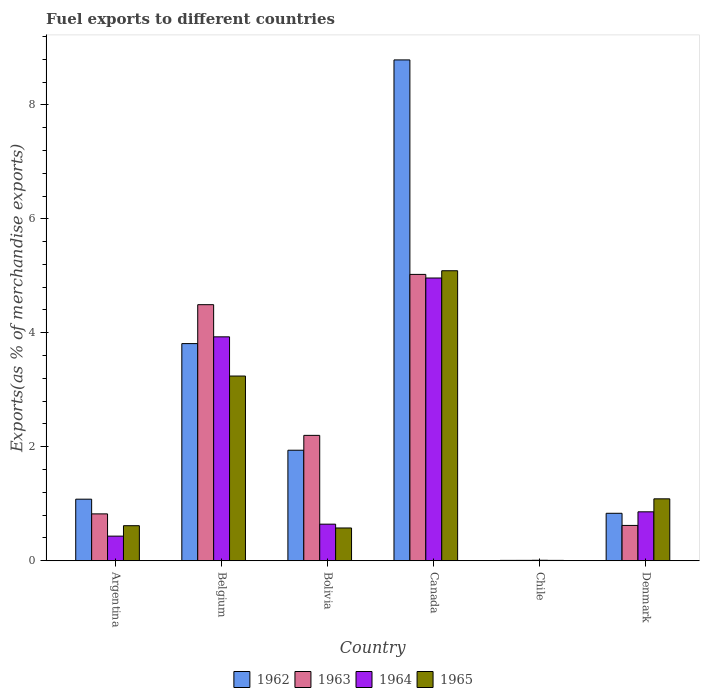Are the number of bars on each tick of the X-axis equal?
Provide a short and direct response. Yes. How many bars are there on the 2nd tick from the left?
Ensure brevity in your answer.  4. What is the percentage of exports to different countries in 1962 in Denmark?
Offer a very short reply. 0.83. Across all countries, what is the maximum percentage of exports to different countries in 1965?
Make the answer very short. 5.09. Across all countries, what is the minimum percentage of exports to different countries in 1963?
Ensure brevity in your answer.  0.01. What is the total percentage of exports to different countries in 1963 in the graph?
Provide a succinct answer. 13.17. What is the difference between the percentage of exports to different countries in 1964 in Bolivia and that in Denmark?
Your answer should be very brief. -0.22. What is the difference between the percentage of exports to different countries in 1964 in Denmark and the percentage of exports to different countries in 1962 in Belgium?
Provide a short and direct response. -2.95. What is the average percentage of exports to different countries in 1962 per country?
Provide a short and direct response. 2.74. What is the difference between the percentage of exports to different countries of/in 1964 and percentage of exports to different countries of/in 1963 in Belgium?
Offer a terse response. -0.56. In how many countries, is the percentage of exports to different countries in 1962 greater than 6 %?
Make the answer very short. 1. What is the ratio of the percentage of exports to different countries in 1963 in Belgium to that in Chile?
Offer a terse response. 634.23. Is the difference between the percentage of exports to different countries in 1964 in Argentina and Chile greater than the difference between the percentage of exports to different countries in 1963 in Argentina and Chile?
Offer a terse response. No. What is the difference between the highest and the second highest percentage of exports to different countries in 1964?
Keep it short and to the point. -3.07. What is the difference between the highest and the lowest percentage of exports to different countries in 1963?
Offer a very short reply. 5.02. Is it the case that in every country, the sum of the percentage of exports to different countries in 1964 and percentage of exports to different countries in 1963 is greater than the sum of percentage of exports to different countries in 1965 and percentage of exports to different countries in 1962?
Your response must be concise. No. What does the 1st bar from the left in Canada represents?
Offer a very short reply. 1962. What does the 1st bar from the right in Argentina represents?
Make the answer very short. 1965. Are all the bars in the graph horizontal?
Provide a short and direct response. No. How many countries are there in the graph?
Your answer should be very brief. 6. What is the difference between two consecutive major ticks on the Y-axis?
Your response must be concise. 2. Does the graph contain grids?
Offer a very short reply. No. How are the legend labels stacked?
Your answer should be very brief. Horizontal. What is the title of the graph?
Keep it short and to the point. Fuel exports to different countries. Does "1990" appear as one of the legend labels in the graph?
Offer a very short reply. No. What is the label or title of the Y-axis?
Provide a succinct answer. Exports(as % of merchandise exports). What is the Exports(as % of merchandise exports) of 1962 in Argentina?
Ensure brevity in your answer.  1.08. What is the Exports(as % of merchandise exports) of 1963 in Argentina?
Offer a terse response. 0.82. What is the Exports(as % of merchandise exports) of 1964 in Argentina?
Offer a very short reply. 0.43. What is the Exports(as % of merchandise exports) in 1965 in Argentina?
Your response must be concise. 0.62. What is the Exports(as % of merchandise exports) in 1962 in Belgium?
Make the answer very short. 3.81. What is the Exports(as % of merchandise exports) of 1963 in Belgium?
Make the answer very short. 4.49. What is the Exports(as % of merchandise exports) of 1964 in Belgium?
Provide a succinct answer. 3.93. What is the Exports(as % of merchandise exports) of 1965 in Belgium?
Your answer should be compact. 3.24. What is the Exports(as % of merchandise exports) in 1962 in Bolivia?
Make the answer very short. 1.94. What is the Exports(as % of merchandise exports) of 1963 in Bolivia?
Your response must be concise. 2.2. What is the Exports(as % of merchandise exports) in 1964 in Bolivia?
Ensure brevity in your answer.  0.64. What is the Exports(as % of merchandise exports) in 1965 in Bolivia?
Provide a short and direct response. 0.58. What is the Exports(as % of merchandise exports) of 1962 in Canada?
Make the answer very short. 8.79. What is the Exports(as % of merchandise exports) in 1963 in Canada?
Ensure brevity in your answer.  5.02. What is the Exports(as % of merchandise exports) of 1964 in Canada?
Ensure brevity in your answer.  4.96. What is the Exports(as % of merchandise exports) of 1965 in Canada?
Make the answer very short. 5.09. What is the Exports(as % of merchandise exports) in 1962 in Chile?
Provide a short and direct response. 0.01. What is the Exports(as % of merchandise exports) of 1963 in Chile?
Provide a short and direct response. 0.01. What is the Exports(as % of merchandise exports) of 1964 in Chile?
Your response must be concise. 0.01. What is the Exports(as % of merchandise exports) of 1965 in Chile?
Provide a short and direct response. 0.01. What is the Exports(as % of merchandise exports) in 1962 in Denmark?
Offer a very short reply. 0.83. What is the Exports(as % of merchandise exports) of 1963 in Denmark?
Keep it short and to the point. 0.62. What is the Exports(as % of merchandise exports) in 1964 in Denmark?
Offer a very short reply. 0.86. What is the Exports(as % of merchandise exports) of 1965 in Denmark?
Offer a terse response. 1.09. Across all countries, what is the maximum Exports(as % of merchandise exports) in 1962?
Your answer should be compact. 8.79. Across all countries, what is the maximum Exports(as % of merchandise exports) of 1963?
Offer a terse response. 5.02. Across all countries, what is the maximum Exports(as % of merchandise exports) in 1964?
Provide a short and direct response. 4.96. Across all countries, what is the maximum Exports(as % of merchandise exports) of 1965?
Offer a terse response. 5.09. Across all countries, what is the minimum Exports(as % of merchandise exports) of 1962?
Provide a succinct answer. 0.01. Across all countries, what is the minimum Exports(as % of merchandise exports) of 1963?
Keep it short and to the point. 0.01. Across all countries, what is the minimum Exports(as % of merchandise exports) in 1964?
Your answer should be compact. 0.01. Across all countries, what is the minimum Exports(as % of merchandise exports) of 1965?
Your response must be concise. 0.01. What is the total Exports(as % of merchandise exports) in 1962 in the graph?
Offer a terse response. 16.46. What is the total Exports(as % of merchandise exports) of 1963 in the graph?
Give a very brief answer. 13.17. What is the total Exports(as % of merchandise exports) in 1964 in the graph?
Your response must be concise. 10.83. What is the total Exports(as % of merchandise exports) in 1965 in the graph?
Give a very brief answer. 10.61. What is the difference between the Exports(as % of merchandise exports) in 1962 in Argentina and that in Belgium?
Provide a succinct answer. -2.73. What is the difference between the Exports(as % of merchandise exports) in 1963 in Argentina and that in Belgium?
Your answer should be compact. -3.67. What is the difference between the Exports(as % of merchandise exports) in 1964 in Argentina and that in Belgium?
Your answer should be very brief. -3.5. What is the difference between the Exports(as % of merchandise exports) in 1965 in Argentina and that in Belgium?
Keep it short and to the point. -2.63. What is the difference between the Exports(as % of merchandise exports) in 1962 in Argentina and that in Bolivia?
Your response must be concise. -0.86. What is the difference between the Exports(as % of merchandise exports) of 1963 in Argentina and that in Bolivia?
Offer a terse response. -1.38. What is the difference between the Exports(as % of merchandise exports) of 1964 in Argentina and that in Bolivia?
Your answer should be very brief. -0.21. What is the difference between the Exports(as % of merchandise exports) of 1965 in Argentina and that in Bolivia?
Make the answer very short. 0.04. What is the difference between the Exports(as % of merchandise exports) in 1962 in Argentina and that in Canada?
Keep it short and to the point. -7.71. What is the difference between the Exports(as % of merchandise exports) of 1963 in Argentina and that in Canada?
Your answer should be compact. -4.2. What is the difference between the Exports(as % of merchandise exports) in 1964 in Argentina and that in Canada?
Ensure brevity in your answer.  -4.53. What is the difference between the Exports(as % of merchandise exports) of 1965 in Argentina and that in Canada?
Provide a short and direct response. -4.47. What is the difference between the Exports(as % of merchandise exports) of 1962 in Argentina and that in Chile?
Offer a very short reply. 1.07. What is the difference between the Exports(as % of merchandise exports) of 1963 in Argentina and that in Chile?
Your answer should be very brief. 0.82. What is the difference between the Exports(as % of merchandise exports) of 1964 in Argentina and that in Chile?
Provide a succinct answer. 0.42. What is the difference between the Exports(as % of merchandise exports) in 1965 in Argentina and that in Chile?
Offer a terse response. 0.61. What is the difference between the Exports(as % of merchandise exports) in 1962 in Argentina and that in Denmark?
Provide a succinct answer. 0.25. What is the difference between the Exports(as % of merchandise exports) of 1963 in Argentina and that in Denmark?
Offer a very short reply. 0.2. What is the difference between the Exports(as % of merchandise exports) of 1964 in Argentina and that in Denmark?
Your answer should be very brief. -0.43. What is the difference between the Exports(as % of merchandise exports) in 1965 in Argentina and that in Denmark?
Your answer should be compact. -0.47. What is the difference between the Exports(as % of merchandise exports) of 1962 in Belgium and that in Bolivia?
Your answer should be very brief. 1.87. What is the difference between the Exports(as % of merchandise exports) of 1963 in Belgium and that in Bolivia?
Your answer should be very brief. 2.29. What is the difference between the Exports(as % of merchandise exports) of 1964 in Belgium and that in Bolivia?
Your answer should be very brief. 3.29. What is the difference between the Exports(as % of merchandise exports) of 1965 in Belgium and that in Bolivia?
Your answer should be compact. 2.67. What is the difference between the Exports(as % of merchandise exports) of 1962 in Belgium and that in Canada?
Provide a succinct answer. -4.98. What is the difference between the Exports(as % of merchandise exports) in 1963 in Belgium and that in Canada?
Offer a terse response. -0.53. What is the difference between the Exports(as % of merchandise exports) of 1964 in Belgium and that in Canada?
Keep it short and to the point. -1.03. What is the difference between the Exports(as % of merchandise exports) in 1965 in Belgium and that in Canada?
Give a very brief answer. -1.85. What is the difference between the Exports(as % of merchandise exports) of 1962 in Belgium and that in Chile?
Your answer should be very brief. 3.8. What is the difference between the Exports(as % of merchandise exports) of 1963 in Belgium and that in Chile?
Your answer should be very brief. 4.49. What is the difference between the Exports(as % of merchandise exports) in 1964 in Belgium and that in Chile?
Offer a terse response. 3.92. What is the difference between the Exports(as % of merchandise exports) in 1965 in Belgium and that in Chile?
Your response must be concise. 3.23. What is the difference between the Exports(as % of merchandise exports) in 1962 in Belgium and that in Denmark?
Offer a very short reply. 2.98. What is the difference between the Exports(as % of merchandise exports) of 1963 in Belgium and that in Denmark?
Make the answer very short. 3.87. What is the difference between the Exports(as % of merchandise exports) in 1964 in Belgium and that in Denmark?
Your answer should be very brief. 3.07. What is the difference between the Exports(as % of merchandise exports) in 1965 in Belgium and that in Denmark?
Your response must be concise. 2.15. What is the difference between the Exports(as % of merchandise exports) in 1962 in Bolivia and that in Canada?
Keep it short and to the point. -6.85. What is the difference between the Exports(as % of merchandise exports) of 1963 in Bolivia and that in Canada?
Give a very brief answer. -2.82. What is the difference between the Exports(as % of merchandise exports) in 1964 in Bolivia and that in Canada?
Offer a terse response. -4.32. What is the difference between the Exports(as % of merchandise exports) of 1965 in Bolivia and that in Canada?
Offer a terse response. -4.51. What is the difference between the Exports(as % of merchandise exports) of 1962 in Bolivia and that in Chile?
Offer a very short reply. 1.93. What is the difference between the Exports(as % of merchandise exports) in 1963 in Bolivia and that in Chile?
Provide a succinct answer. 2.19. What is the difference between the Exports(as % of merchandise exports) of 1964 in Bolivia and that in Chile?
Offer a very short reply. 0.63. What is the difference between the Exports(as % of merchandise exports) in 1965 in Bolivia and that in Chile?
Give a very brief answer. 0.57. What is the difference between the Exports(as % of merchandise exports) of 1962 in Bolivia and that in Denmark?
Ensure brevity in your answer.  1.11. What is the difference between the Exports(as % of merchandise exports) in 1963 in Bolivia and that in Denmark?
Your response must be concise. 1.58. What is the difference between the Exports(as % of merchandise exports) in 1964 in Bolivia and that in Denmark?
Your answer should be very brief. -0.22. What is the difference between the Exports(as % of merchandise exports) of 1965 in Bolivia and that in Denmark?
Give a very brief answer. -0.51. What is the difference between the Exports(as % of merchandise exports) of 1962 in Canada and that in Chile?
Ensure brevity in your answer.  8.78. What is the difference between the Exports(as % of merchandise exports) of 1963 in Canada and that in Chile?
Provide a succinct answer. 5.02. What is the difference between the Exports(as % of merchandise exports) of 1964 in Canada and that in Chile?
Make the answer very short. 4.95. What is the difference between the Exports(as % of merchandise exports) in 1965 in Canada and that in Chile?
Your response must be concise. 5.08. What is the difference between the Exports(as % of merchandise exports) in 1962 in Canada and that in Denmark?
Your response must be concise. 7.95. What is the difference between the Exports(as % of merchandise exports) of 1963 in Canada and that in Denmark?
Provide a short and direct response. 4.4. What is the difference between the Exports(as % of merchandise exports) in 1964 in Canada and that in Denmark?
Offer a very short reply. 4.1. What is the difference between the Exports(as % of merchandise exports) of 1965 in Canada and that in Denmark?
Give a very brief answer. 4. What is the difference between the Exports(as % of merchandise exports) of 1962 in Chile and that in Denmark?
Give a very brief answer. -0.83. What is the difference between the Exports(as % of merchandise exports) in 1963 in Chile and that in Denmark?
Your response must be concise. -0.61. What is the difference between the Exports(as % of merchandise exports) in 1964 in Chile and that in Denmark?
Provide a short and direct response. -0.85. What is the difference between the Exports(as % of merchandise exports) in 1965 in Chile and that in Denmark?
Your response must be concise. -1.08. What is the difference between the Exports(as % of merchandise exports) in 1962 in Argentina and the Exports(as % of merchandise exports) in 1963 in Belgium?
Provide a short and direct response. -3.41. What is the difference between the Exports(as % of merchandise exports) in 1962 in Argentina and the Exports(as % of merchandise exports) in 1964 in Belgium?
Your response must be concise. -2.85. What is the difference between the Exports(as % of merchandise exports) in 1962 in Argentina and the Exports(as % of merchandise exports) in 1965 in Belgium?
Give a very brief answer. -2.16. What is the difference between the Exports(as % of merchandise exports) in 1963 in Argentina and the Exports(as % of merchandise exports) in 1964 in Belgium?
Offer a terse response. -3.11. What is the difference between the Exports(as % of merchandise exports) in 1963 in Argentina and the Exports(as % of merchandise exports) in 1965 in Belgium?
Provide a succinct answer. -2.42. What is the difference between the Exports(as % of merchandise exports) of 1964 in Argentina and the Exports(as % of merchandise exports) of 1965 in Belgium?
Make the answer very short. -2.81. What is the difference between the Exports(as % of merchandise exports) in 1962 in Argentina and the Exports(as % of merchandise exports) in 1963 in Bolivia?
Provide a succinct answer. -1.12. What is the difference between the Exports(as % of merchandise exports) in 1962 in Argentina and the Exports(as % of merchandise exports) in 1964 in Bolivia?
Give a very brief answer. 0.44. What is the difference between the Exports(as % of merchandise exports) of 1962 in Argentina and the Exports(as % of merchandise exports) of 1965 in Bolivia?
Provide a succinct answer. 0.51. What is the difference between the Exports(as % of merchandise exports) in 1963 in Argentina and the Exports(as % of merchandise exports) in 1964 in Bolivia?
Give a very brief answer. 0.18. What is the difference between the Exports(as % of merchandise exports) in 1963 in Argentina and the Exports(as % of merchandise exports) in 1965 in Bolivia?
Your response must be concise. 0.25. What is the difference between the Exports(as % of merchandise exports) in 1964 in Argentina and the Exports(as % of merchandise exports) in 1965 in Bolivia?
Offer a very short reply. -0.14. What is the difference between the Exports(as % of merchandise exports) in 1962 in Argentina and the Exports(as % of merchandise exports) in 1963 in Canada?
Offer a terse response. -3.94. What is the difference between the Exports(as % of merchandise exports) of 1962 in Argentina and the Exports(as % of merchandise exports) of 1964 in Canada?
Offer a terse response. -3.88. What is the difference between the Exports(as % of merchandise exports) of 1962 in Argentina and the Exports(as % of merchandise exports) of 1965 in Canada?
Keep it short and to the point. -4.01. What is the difference between the Exports(as % of merchandise exports) in 1963 in Argentina and the Exports(as % of merchandise exports) in 1964 in Canada?
Keep it short and to the point. -4.14. What is the difference between the Exports(as % of merchandise exports) in 1963 in Argentina and the Exports(as % of merchandise exports) in 1965 in Canada?
Offer a very short reply. -4.27. What is the difference between the Exports(as % of merchandise exports) in 1964 in Argentina and the Exports(as % of merchandise exports) in 1965 in Canada?
Your answer should be compact. -4.66. What is the difference between the Exports(as % of merchandise exports) in 1962 in Argentina and the Exports(as % of merchandise exports) in 1963 in Chile?
Your answer should be very brief. 1.07. What is the difference between the Exports(as % of merchandise exports) in 1962 in Argentina and the Exports(as % of merchandise exports) in 1964 in Chile?
Your response must be concise. 1.07. What is the difference between the Exports(as % of merchandise exports) in 1962 in Argentina and the Exports(as % of merchandise exports) in 1965 in Chile?
Provide a succinct answer. 1.07. What is the difference between the Exports(as % of merchandise exports) in 1963 in Argentina and the Exports(as % of merchandise exports) in 1964 in Chile?
Keep it short and to the point. 0.81. What is the difference between the Exports(as % of merchandise exports) of 1963 in Argentina and the Exports(as % of merchandise exports) of 1965 in Chile?
Ensure brevity in your answer.  0.82. What is the difference between the Exports(as % of merchandise exports) in 1964 in Argentina and the Exports(as % of merchandise exports) in 1965 in Chile?
Offer a very short reply. 0.43. What is the difference between the Exports(as % of merchandise exports) in 1962 in Argentina and the Exports(as % of merchandise exports) in 1963 in Denmark?
Your response must be concise. 0.46. What is the difference between the Exports(as % of merchandise exports) in 1962 in Argentina and the Exports(as % of merchandise exports) in 1964 in Denmark?
Make the answer very short. 0.22. What is the difference between the Exports(as % of merchandise exports) of 1962 in Argentina and the Exports(as % of merchandise exports) of 1965 in Denmark?
Provide a succinct answer. -0.01. What is the difference between the Exports(as % of merchandise exports) in 1963 in Argentina and the Exports(as % of merchandise exports) in 1964 in Denmark?
Your response must be concise. -0.04. What is the difference between the Exports(as % of merchandise exports) in 1963 in Argentina and the Exports(as % of merchandise exports) in 1965 in Denmark?
Offer a very short reply. -0.26. What is the difference between the Exports(as % of merchandise exports) of 1964 in Argentina and the Exports(as % of merchandise exports) of 1965 in Denmark?
Provide a short and direct response. -0.65. What is the difference between the Exports(as % of merchandise exports) of 1962 in Belgium and the Exports(as % of merchandise exports) of 1963 in Bolivia?
Provide a short and direct response. 1.61. What is the difference between the Exports(as % of merchandise exports) in 1962 in Belgium and the Exports(as % of merchandise exports) in 1964 in Bolivia?
Provide a short and direct response. 3.17. What is the difference between the Exports(as % of merchandise exports) in 1962 in Belgium and the Exports(as % of merchandise exports) in 1965 in Bolivia?
Make the answer very short. 3.23. What is the difference between the Exports(as % of merchandise exports) of 1963 in Belgium and the Exports(as % of merchandise exports) of 1964 in Bolivia?
Give a very brief answer. 3.85. What is the difference between the Exports(as % of merchandise exports) in 1963 in Belgium and the Exports(as % of merchandise exports) in 1965 in Bolivia?
Offer a terse response. 3.92. What is the difference between the Exports(as % of merchandise exports) of 1964 in Belgium and the Exports(as % of merchandise exports) of 1965 in Bolivia?
Provide a succinct answer. 3.35. What is the difference between the Exports(as % of merchandise exports) in 1962 in Belgium and the Exports(as % of merchandise exports) in 1963 in Canada?
Your answer should be compact. -1.21. What is the difference between the Exports(as % of merchandise exports) in 1962 in Belgium and the Exports(as % of merchandise exports) in 1964 in Canada?
Ensure brevity in your answer.  -1.15. What is the difference between the Exports(as % of merchandise exports) in 1962 in Belgium and the Exports(as % of merchandise exports) in 1965 in Canada?
Make the answer very short. -1.28. What is the difference between the Exports(as % of merchandise exports) in 1963 in Belgium and the Exports(as % of merchandise exports) in 1964 in Canada?
Provide a succinct answer. -0.47. What is the difference between the Exports(as % of merchandise exports) of 1963 in Belgium and the Exports(as % of merchandise exports) of 1965 in Canada?
Offer a terse response. -0.6. What is the difference between the Exports(as % of merchandise exports) in 1964 in Belgium and the Exports(as % of merchandise exports) in 1965 in Canada?
Offer a terse response. -1.16. What is the difference between the Exports(as % of merchandise exports) of 1962 in Belgium and the Exports(as % of merchandise exports) of 1963 in Chile?
Offer a terse response. 3.8. What is the difference between the Exports(as % of merchandise exports) of 1962 in Belgium and the Exports(as % of merchandise exports) of 1964 in Chile?
Your answer should be very brief. 3.8. What is the difference between the Exports(as % of merchandise exports) in 1962 in Belgium and the Exports(as % of merchandise exports) in 1965 in Chile?
Your response must be concise. 3.8. What is the difference between the Exports(as % of merchandise exports) of 1963 in Belgium and the Exports(as % of merchandise exports) of 1964 in Chile?
Provide a succinct answer. 4.48. What is the difference between the Exports(as % of merchandise exports) of 1963 in Belgium and the Exports(as % of merchandise exports) of 1965 in Chile?
Provide a succinct answer. 4.49. What is the difference between the Exports(as % of merchandise exports) of 1964 in Belgium and the Exports(as % of merchandise exports) of 1965 in Chile?
Your response must be concise. 3.92. What is the difference between the Exports(as % of merchandise exports) in 1962 in Belgium and the Exports(as % of merchandise exports) in 1963 in Denmark?
Offer a terse response. 3.19. What is the difference between the Exports(as % of merchandise exports) of 1962 in Belgium and the Exports(as % of merchandise exports) of 1964 in Denmark?
Keep it short and to the point. 2.95. What is the difference between the Exports(as % of merchandise exports) in 1962 in Belgium and the Exports(as % of merchandise exports) in 1965 in Denmark?
Your answer should be very brief. 2.72. What is the difference between the Exports(as % of merchandise exports) in 1963 in Belgium and the Exports(as % of merchandise exports) in 1964 in Denmark?
Your response must be concise. 3.63. What is the difference between the Exports(as % of merchandise exports) of 1963 in Belgium and the Exports(as % of merchandise exports) of 1965 in Denmark?
Your answer should be very brief. 3.41. What is the difference between the Exports(as % of merchandise exports) of 1964 in Belgium and the Exports(as % of merchandise exports) of 1965 in Denmark?
Your answer should be very brief. 2.84. What is the difference between the Exports(as % of merchandise exports) of 1962 in Bolivia and the Exports(as % of merchandise exports) of 1963 in Canada?
Make the answer very short. -3.08. What is the difference between the Exports(as % of merchandise exports) of 1962 in Bolivia and the Exports(as % of merchandise exports) of 1964 in Canada?
Ensure brevity in your answer.  -3.02. What is the difference between the Exports(as % of merchandise exports) of 1962 in Bolivia and the Exports(as % of merchandise exports) of 1965 in Canada?
Provide a short and direct response. -3.15. What is the difference between the Exports(as % of merchandise exports) of 1963 in Bolivia and the Exports(as % of merchandise exports) of 1964 in Canada?
Make the answer very short. -2.76. What is the difference between the Exports(as % of merchandise exports) of 1963 in Bolivia and the Exports(as % of merchandise exports) of 1965 in Canada?
Offer a very short reply. -2.89. What is the difference between the Exports(as % of merchandise exports) of 1964 in Bolivia and the Exports(as % of merchandise exports) of 1965 in Canada?
Give a very brief answer. -4.45. What is the difference between the Exports(as % of merchandise exports) in 1962 in Bolivia and the Exports(as % of merchandise exports) in 1963 in Chile?
Offer a terse response. 1.93. What is the difference between the Exports(as % of merchandise exports) of 1962 in Bolivia and the Exports(as % of merchandise exports) of 1964 in Chile?
Offer a terse response. 1.93. What is the difference between the Exports(as % of merchandise exports) in 1962 in Bolivia and the Exports(as % of merchandise exports) in 1965 in Chile?
Your response must be concise. 1.93. What is the difference between the Exports(as % of merchandise exports) of 1963 in Bolivia and the Exports(as % of merchandise exports) of 1964 in Chile?
Give a very brief answer. 2.19. What is the difference between the Exports(as % of merchandise exports) in 1963 in Bolivia and the Exports(as % of merchandise exports) in 1965 in Chile?
Your response must be concise. 2.19. What is the difference between the Exports(as % of merchandise exports) in 1964 in Bolivia and the Exports(as % of merchandise exports) in 1965 in Chile?
Offer a terse response. 0.64. What is the difference between the Exports(as % of merchandise exports) in 1962 in Bolivia and the Exports(as % of merchandise exports) in 1963 in Denmark?
Give a very brief answer. 1.32. What is the difference between the Exports(as % of merchandise exports) in 1962 in Bolivia and the Exports(as % of merchandise exports) in 1964 in Denmark?
Provide a succinct answer. 1.08. What is the difference between the Exports(as % of merchandise exports) in 1962 in Bolivia and the Exports(as % of merchandise exports) in 1965 in Denmark?
Provide a succinct answer. 0.85. What is the difference between the Exports(as % of merchandise exports) in 1963 in Bolivia and the Exports(as % of merchandise exports) in 1964 in Denmark?
Give a very brief answer. 1.34. What is the difference between the Exports(as % of merchandise exports) of 1963 in Bolivia and the Exports(as % of merchandise exports) of 1965 in Denmark?
Give a very brief answer. 1.11. What is the difference between the Exports(as % of merchandise exports) of 1964 in Bolivia and the Exports(as % of merchandise exports) of 1965 in Denmark?
Make the answer very short. -0.44. What is the difference between the Exports(as % of merchandise exports) of 1962 in Canada and the Exports(as % of merchandise exports) of 1963 in Chile?
Provide a succinct answer. 8.78. What is the difference between the Exports(as % of merchandise exports) of 1962 in Canada and the Exports(as % of merchandise exports) of 1964 in Chile?
Give a very brief answer. 8.78. What is the difference between the Exports(as % of merchandise exports) of 1962 in Canada and the Exports(as % of merchandise exports) of 1965 in Chile?
Provide a succinct answer. 8.78. What is the difference between the Exports(as % of merchandise exports) of 1963 in Canada and the Exports(as % of merchandise exports) of 1964 in Chile?
Ensure brevity in your answer.  5.02. What is the difference between the Exports(as % of merchandise exports) in 1963 in Canada and the Exports(as % of merchandise exports) in 1965 in Chile?
Your answer should be very brief. 5.02. What is the difference between the Exports(as % of merchandise exports) of 1964 in Canada and the Exports(as % of merchandise exports) of 1965 in Chile?
Your answer should be compact. 4.95. What is the difference between the Exports(as % of merchandise exports) of 1962 in Canada and the Exports(as % of merchandise exports) of 1963 in Denmark?
Ensure brevity in your answer.  8.17. What is the difference between the Exports(as % of merchandise exports) in 1962 in Canada and the Exports(as % of merchandise exports) in 1964 in Denmark?
Make the answer very short. 7.93. What is the difference between the Exports(as % of merchandise exports) of 1962 in Canada and the Exports(as % of merchandise exports) of 1965 in Denmark?
Provide a succinct answer. 7.7. What is the difference between the Exports(as % of merchandise exports) of 1963 in Canada and the Exports(as % of merchandise exports) of 1964 in Denmark?
Ensure brevity in your answer.  4.17. What is the difference between the Exports(as % of merchandise exports) in 1963 in Canada and the Exports(as % of merchandise exports) in 1965 in Denmark?
Provide a succinct answer. 3.94. What is the difference between the Exports(as % of merchandise exports) in 1964 in Canada and the Exports(as % of merchandise exports) in 1965 in Denmark?
Offer a terse response. 3.87. What is the difference between the Exports(as % of merchandise exports) in 1962 in Chile and the Exports(as % of merchandise exports) in 1963 in Denmark?
Your answer should be very brief. -0.61. What is the difference between the Exports(as % of merchandise exports) in 1962 in Chile and the Exports(as % of merchandise exports) in 1964 in Denmark?
Ensure brevity in your answer.  -0.85. What is the difference between the Exports(as % of merchandise exports) of 1962 in Chile and the Exports(as % of merchandise exports) of 1965 in Denmark?
Offer a terse response. -1.08. What is the difference between the Exports(as % of merchandise exports) of 1963 in Chile and the Exports(as % of merchandise exports) of 1964 in Denmark?
Offer a very short reply. -0.85. What is the difference between the Exports(as % of merchandise exports) in 1963 in Chile and the Exports(as % of merchandise exports) in 1965 in Denmark?
Provide a succinct answer. -1.08. What is the difference between the Exports(as % of merchandise exports) of 1964 in Chile and the Exports(as % of merchandise exports) of 1965 in Denmark?
Your answer should be very brief. -1.08. What is the average Exports(as % of merchandise exports) of 1962 per country?
Keep it short and to the point. 2.74. What is the average Exports(as % of merchandise exports) of 1963 per country?
Make the answer very short. 2.19. What is the average Exports(as % of merchandise exports) in 1964 per country?
Ensure brevity in your answer.  1.81. What is the average Exports(as % of merchandise exports) of 1965 per country?
Provide a short and direct response. 1.77. What is the difference between the Exports(as % of merchandise exports) of 1962 and Exports(as % of merchandise exports) of 1963 in Argentina?
Give a very brief answer. 0.26. What is the difference between the Exports(as % of merchandise exports) of 1962 and Exports(as % of merchandise exports) of 1964 in Argentina?
Your answer should be very brief. 0.65. What is the difference between the Exports(as % of merchandise exports) in 1962 and Exports(as % of merchandise exports) in 1965 in Argentina?
Keep it short and to the point. 0.47. What is the difference between the Exports(as % of merchandise exports) in 1963 and Exports(as % of merchandise exports) in 1964 in Argentina?
Provide a succinct answer. 0.39. What is the difference between the Exports(as % of merchandise exports) in 1963 and Exports(as % of merchandise exports) in 1965 in Argentina?
Offer a very short reply. 0.21. What is the difference between the Exports(as % of merchandise exports) of 1964 and Exports(as % of merchandise exports) of 1965 in Argentina?
Ensure brevity in your answer.  -0.18. What is the difference between the Exports(as % of merchandise exports) in 1962 and Exports(as % of merchandise exports) in 1963 in Belgium?
Give a very brief answer. -0.68. What is the difference between the Exports(as % of merchandise exports) of 1962 and Exports(as % of merchandise exports) of 1964 in Belgium?
Provide a short and direct response. -0.12. What is the difference between the Exports(as % of merchandise exports) in 1962 and Exports(as % of merchandise exports) in 1965 in Belgium?
Offer a terse response. 0.57. What is the difference between the Exports(as % of merchandise exports) in 1963 and Exports(as % of merchandise exports) in 1964 in Belgium?
Provide a short and direct response. 0.56. What is the difference between the Exports(as % of merchandise exports) in 1963 and Exports(as % of merchandise exports) in 1965 in Belgium?
Keep it short and to the point. 1.25. What is the difference between the Exports(as % of merchandise exports) of 1964 and Exports(as % of merchandise exports) of 1965 in Belgium?
Provide a succinct answer. 0.69. What is the difference between the Exports(as % of merchandise exports) in 1962 and Exports(as % of merchandise exports) in 1963 in Bolivia?
Keep it short and to the point. -0.26. What is the difference between the Exports(as % of merchandise exports) of 1962 and Exports(as % of merchandise exports) of 1964 in Bolivia?
Your response must be concise. 1.3. What is the difference between the Exports(as % of merchandise exports) of 1962 and Exports(as % of merchandise exports) of 1965 in Bolivia?
Make the answer very short. 1.36. What is the difference between the Exports(as % of merchandise exports) in 1963 and Exports(as % of merchandise exports) in 1964 in Bolivia?
Your answer should be very brief. 1.56. What is the difference between the Exports(as % of merchandise exports) in 1963 and Exports(as % of merchandise exports) in 1965 in Bolivia?
Your answer should be very brief. 1.62. What is the difference between the Exports(as % of merchandise exports) in 1964 and Exports(as % of merchandise exports) in 1965 in Bolivia?
Give a very brief answer. 0.07. What is the difference between the Exports(as % of merchandise exports) of 1962 and Exports(as % of merchandise exports) of 1963 in Canada?
Give a very brief answer. 3.76. What is the difference between the Exports(as % of merchandise exports) in 1962 and Exports(as % of merchandise exports) in 1964 in Canada?
Offer a terse response. 3.83. What is the difference between the Exports(as % of merchandise exports) in 1962 and Exports(as % of merchandise exports) in 1965 in Canada?
Your answer should be very brief. 3.7. What is the difference between the Exports(as % of merchandise exports) of 1963 and Exports(as % of merchandise exports) of 1964 in Canada?
Keep it short and to the point. 0.06. What is the difference between the Exports(as % of merchandise exports) in 1963 and Exports(as % of merchandise exports) in 1965 in Canada?
Provide a succinct answer. -0.06. What is the difference between the Exports(as % of merchandise exports) of 1964 and Exports(as % of merchandise exports) of 1965 in Canada?
Make the answer very short. -0.13. What is the difference between the Exports(as % of merchandise exports) of 1962 and Exports(as % of merchandise exports) of 1963 in Chile?
Ensure brevity in your answer.  -0. What is the difference between the Exports(as % of merchandise exports) of 1962 and Exports(as % of merchandise exports) of 1964 in Chile?
Your answer should be compact. -0. What is the difference between the Exports(as % of merchandise exports) of 1962 and Exports(as % of merchandise exports) of 1965 in Chile?
Keep it short and to the point. 0. What is the difference between the Exports(as % of merchandise exports) in 1963 and Exports(as % of merchandise exports) in 1964 in Chile?
Provide a succinct answer. -0. What is the difference between the Exports(as % of merchandise exports) of 1964 and Exports(as % of merchandise exports) of 1965 in Chile?
Your response must be concise. 0. What is the difference between the Exports(as % of merchandise exports) in 1962 and Exports(as % of merchandise exports) in 1963 in Denmark?
Provide a succinct answer. 0.21. What is the difference between the Exports(as % of merchandise exports) in 1962 and Exports(as % of merchandise exports) in 1964 in Denmark?
Your answer should be compact. -0.03. What is the difference between the Exports(as % of merchandise exports) of 1962 and Exports(as % of merchandise exports) of 1965 in Denmark?
Offer a terse response. -0.25. What is the difference between the Exports(as % of merchandise exports) of 1963 and Exports(as % of merchandise exports) of 1964 in Denmark?
Your answer should be very brief. -0.24. What is the difference between the Exports(as % of merchandise exports) in 1963 and Exports(as % of merchandise exports) in 1965 in Denmark?
Ensure brevity in your answer.  -0.47. What is the difference between the Exports(as % of merchandise exports) of 1964 and Exports(as % of merchandise exports) of 1965 in Denmark?
Provide a short and direct response. -0.23. What is the ratio of the Exports(as % of merchandise exports) in 1962 in Argentina to that in Belgium?
Keep it short and to the point. 0.28. What is the ratio of the Exports(as % of merchandise exports) in 1963 in Argentina to that in Belgium?
Make the answer very short. 0.18. What is the ratio of the Exports(as % of merchandise exports) of 1964 in Argentina to that in Belgium?
Provide a short and direct response. 0.11. What is the ratio of the Exports(as % of merchandise exports) in 1965 in Argentina to that in Belgium?
Keep it short and to the point. 0.19. What is the ratio of the Exports(as % of merchandise exports) in 1962 in Argentina to that in Bolivia?
Provide a short and direct response. 0.56. What is the ratio of the Exports(as % of merchandise exports) in 1963 in Argentina to that in Bolivia?
Offer a terse response. 0.37. What is the ratio of the Exports(as % of merchandise exports) in 1964 in Argentina to that in Bolivia?
Provide a succinct answer. 0.67. What is the ratio of the Exports(as % of merchandise exports) of 1965 in Argentina to that in Bolivia?
Offer a terse response. 1.07. What is the ratio of the Exports(as % of merchandise exports) of 1962 in Argentina to that in Canada?
Provide a succinct answer. 0.12. What is the ratio of the Exports(as % of merchandise exports) of 1963 in Argentina to that in Canada?
Provide a short and direct response. 0.16. What is the ratio of the Exports(as % of merchandise exports) of 1964 in Argentina to that in Canada?
Provide a short and direct response. 0.09. What is the ratio of the Exports(as % of merchandise exports) of 1965 in Argentina to that in Canada?
Give a very brief answer. 0.12. What is the ratio of the Exports(as % of merchandise exports) in 1962 in Argentina to that in Chile?
Ensure brevity in your answer.  154.28. What is the ratio of the Exports(as % of merchandise exports) of 1963 in Argentina to that in Chile?
Give a very brief answer. 116.11. What is the ratio of the Exports(as % of merchandise exports) in 1964 in Argentina to that in Chile?
Your response must be concise. 48.39. What is the ratio of the Exports(as % of merchandise exports) in 1965 in Argentina to that in Chile?
Offer a terse response. 91.07. What is the ratio of the Exports(as % of merchandise exports) of 1962 in Argentina to that in Denmark?
Your answer should be compact. 1.3. What is the ratio of the Exports(as % of merchandise exports) of 1963 in Argentina to that in Denmark?
Provide a short and direct response. 1.33. What is the ratio of the Exports(as % of merchandise exports) of 1964 in Argentina to that in Denmark?
Your answer should be very brief. 0.5. What is the ratio of the Exports(as % of merchandise exports) in 1965 in Argentina to that in Denmark?
Your answer should be compact. 0.57. What is the ratio of the Exports(as % of merchandise exports) in 1962 in Belgium to that in Bolivia?
Ensure brevity in your answer.  1.96. What is the ratio of the Exports(as % of merchandise exports) of 1963 in Belgium to that in Bolivia?
Give a very brief answer. 2.04. What is the ratio of the Exports(as % of merchandise exports) of 1964 in Belgium to that in Bolivia?
Make the answer very short. 6.12. What is the ratio of the Exports(as % of merchandise exports) of 1965 in Belgium to that in Bolivia?
Give a very brief answer. 5.63. What is the ratio of the Exports(as % of merchandise exports) in 1962 in Belgium to that in Canada?
Offer a very short reply. 0.43. What is the ratio of the Exports(as % of merchandise exports) in 1963 in Belgium to that in Canada?
Your answer should be very brief. 0.89. What is the ratio of the Exports(as % of merchandise exports) of 1964 in Belgium to that in Canada?
Provide a succinct answer. 0.79. What is the ratio of the Exports(as % of merchandise exports) in 1965 in Belgium to that in Canada?
Your response must be concise. 0.64. What is the ratio of the Exports(as % of merchandise exports) of 1962 in Belgium to that in Chile?
Your answer should be very brief. 543.89. What is the ratio of the Exports(as % of merchandise exports) in 1963 in Belgium to that in Chile?
Offer a terse response. 634.23. What is the ratio of the Exports(as % of merchandise exports) of 1964 in Belgium to that in Chile?
Offer a terse response. 439.88. What is the ratio of the Exports(as % of merchandise exports) of 1965 in Belgium to that in Chile?
Offer a very short reply. 479.5. What is the ratio of the Exports(as % of merchandise exports) of 1962 in Belgium to that in Denmark?
Your answer should be very brief. 4.57. What is the ratio of the Exports(as % of merchandise exports) of 1963 in Belgium to that in Denmark?
Provide a succinct answer. 7.24. What is the ratio of the Exports(as % of merchandise exports) of 1964 in Belgium to that in Denmark?
Your answer should be compact. 4.57. What is the ratio of the Exports(as % of merchandise exports) of 1965 in Belgium to that in Denmark?
Give a very brief answer. 2.98. What is the ratio of the Exports(as % of merchandise exports) of 1962 in Bolivia to that in Canada?
Your answer should be very brief. 0.22. What is the ratio of the Exports(as % of merchandise exports) of 1963 in Bolivia to that in Canada?
Your answer should be compact. 0.44. What is the ratio of the Exports(as % of merchandise exports) in 1964 in Bolivia to that in Canada?
Provide a short and direct response. 0.13. What is the ratio of the Exports(as % of merchandise exports) of 1965 in Bolivia to that in Canada?
Ensure brevity in your answer.  0.11. What is the ratio of the Exports(as % of merchandise exports) of 1962 in Bolivia to that in Chile?
Your answer should be very brief. 276.87. What is the ratio of the Exports(as % of merchandise exports) in 1963 in Bolivia to that in Chile?
Give a very brief answer. 310.59. What is the ratio of the Exports(as % of merchandise exports) in 1964 in Bolivia to that in Chile?
Offer a terse response. 71.92. What is the ratio of the Exports(as % of merchandise exports) in 1965 in Bolivia to that in Chile?
Your answer should be very brief. 85.13. What is the ratio of the Exports(as % of merchandise exports) in 1962 in Bolivia to that in Denmark?
Provide a succinct answer. 2.33. What is the ratio of the Exports(as % of merchandise exports) in 1963 in Bolivia to that in Denmark?
Give a very brief answer. 3.55. What is the ratio of the Exports(as % of merchandise exports) in 1964 in Bolivia to that in Denmark?
Your response must be concise. 0.75. What is the ratio of the Exports(as % of merchandise exports) in 1965 in Bolivia to that in Denmark?
Provide a succinct answer. 0.53. What is the ratio of the Exports(as % of merchandise exports) in 1962 in Canada to that in Chile?
Keep it short and to the point. 1254.38. What is the ratio of the Exports(as % of merchandise exports) in 1963 in Canada to that in Chile?
Give a very brief answer. 709.22. What is the ratio of the Exports(as % of merchandise exports) in 1964 in Canada to that in Chile?
Make the answer very short. 555.45. What is the ratio of the Exports(as % of merchandise exports) in 1965 in Canada to that in Chile?
Provide a short and direct response. 752.83. What is the ratio of the Exports(as % of merchandise exports) in 1962 in Canada to that in Denmark?
Offer a very short reply. 10.55. What is the ratio of the Exports(as % of merchandise exports) in 1963 in Canada to that in Denmark?
Offer a very short reply. 8.1. What is the ratio of the Exports(as % of merchandise exports) of 1964 in Canada to that in Denmark?
Provide a succinct answer. 5.78. What is the ratio of the Exports(as % of merchandise exports) of 1965 in Canada to that in Denmark?
Ensure brevity in your answer.  4.68. What is the ratio of the Exports(as % of merchandise exports) in 1962 in Chile to that in Denmark?
Offer a very short reply. 0.01. What is the ratio of the Exports(as % of merchandise exports) in 1963 in Chile to that in Denmark?
Provide a short and direct response. 0.01. What is the ratio of the Exports(as % of merchandise exports) of 1964 in Chile to that in Denmark?
Provide a succinct answer. 0.01. What is the ratio of the Exports(as % of merchandise exports) in 1965 in Chile to that in Denmark?
Provide a short and direct response. 0.01. What is the difference between the highest and the second highest Exports(as % of merchandise exports) of 1962?
Provide a short and direct response. 4.98. What is the difference between the highest and the second highest Exports(as % of merchandise exports) of 1963?
Provide a short and direct response. 0.53. What is the difference between the highest and the second highest Exports(as % of merchandise exports) in 1964?
Keep it short and to the point. 1.03. What is the difference between the highest and the second highest Exports(as % of merchandise exports) in 1965?
Ensure brevity in your answer.  1.85. What is the difference between the highest and the lowest Exports(as % of merchandise exports) in 1962?
Ensure brevity in your answer.  8.78. What is the difference between the highest and the lowest Exports(as % of merchandise exports) in 1963?
Your answer should be very brief. 5.02. What is the difference between the highest and the lowest Exports(as % of merchandise exports) of 1964?
Ensure brevity in your answer.  4.95. What is the difference between the highest and the lowest Exports(as % of merchandise exports) in 1965?
Give a very brief answer. 5.08. 